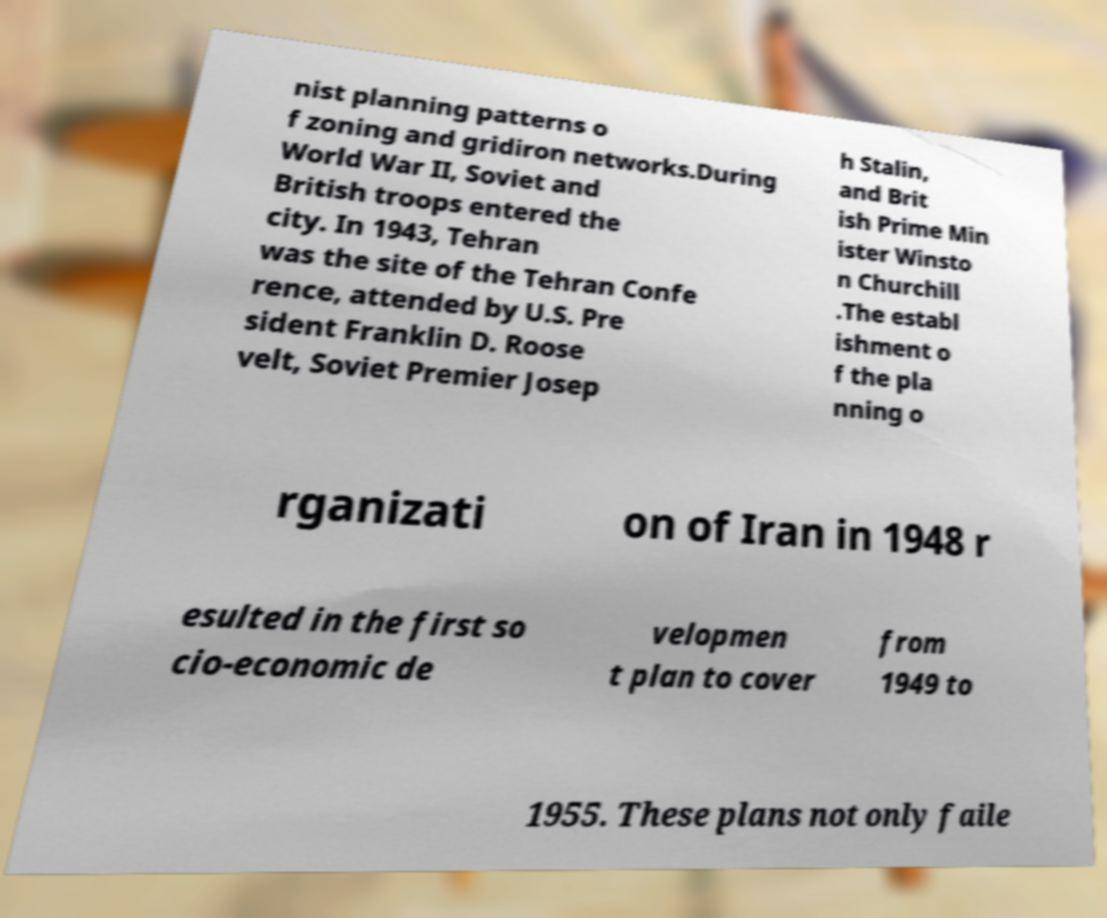For documentation purposes, I need the text within this image transcribed. Could you provide that? nist planning patterns o f zoning and gridiron networks.During World War II, Soviet and British troops entered the city. In 1943, Tehran was the site of the Tehran Confe rence, attended by U.S. Pre sident Franklin D. Roose velt, Soviet Premier Josep h Stalin, and Brit ish Prime Min ister Winsto n Churchill .The establ ishment o f the pla nning o rganizati on of Iran in 1948 r esulted in the first so cio-economic de velopmen t plan to cover from 1949 to 1955. These plans not only faile 